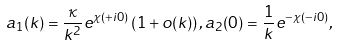Convert formula to latex. <formula><loc_0><loc_0><loc_500><loc_500>a _ { 1 } ( k ) = \frac { \kappa } { k ^ { 2 } } e ^ { \chi ( + i 0 ) } \left ( 1 + o ( k ) \right ) , a _ { 2 } ( 0 ) = \frac { 1 } { k } e ^ { - \chi ( - i 0 ) } ,</formula> 